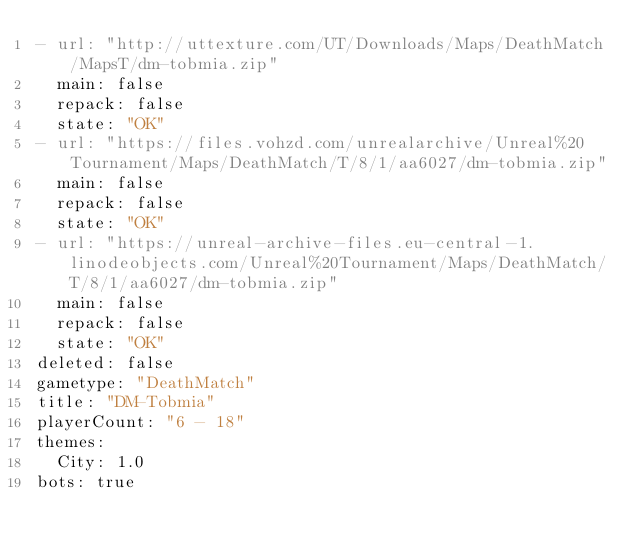Convert code to text. <code><loc_0><loc_0><loc_500><loc_500><_YAML_>- url: "http://uttexture.com/UT/Downloads/Maps/DeathMatch/MapsT/dm-tobmia.zip"
  main: false
  repack: false
  state: "OK"
- url: "https://files.vohzd.com/unrealarchive/Unreal%20Tournament/Maps/DeathMatch/T/8/1/aa6027/dm-tobmia.zip"
  main: false
  repack: false
  state: "OK"
- url: "https://unreal-archive-files.eu-central-1.linodeobjects.com/Unreal%20Tournament/Maps/DeathMatch/T/8/1/aa6027/dm-tobmia.zip"
  main: false
  repack: false
  state: "OK"
deleted: false
gametype: "DeathMatch"
title: "DM-Tobmia"
playerCount: "6 - 18"
themes:
  City: 1.0
bots: true
</code> 